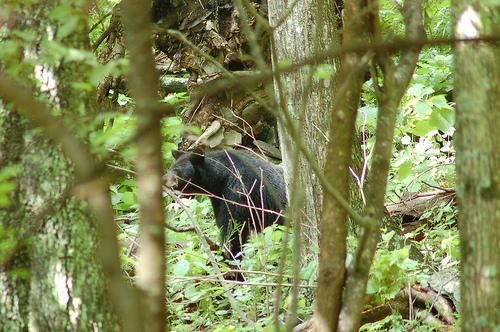Write a short overview of the main subject in the image and its setting. Black bear standing among trees, with a hole in dry log and bark of a tree visible. In a few words, describe the key object in the image and its immediate surroundings. Black bear in natural habitat among trunks of trees and dry twigs. Describe the image's central character and its backdrop in a single sentence. An omnivorous mammal is surrounded by green leaves and tree trunks in a wooded area. Provide a brief description of the primary subject and its surroundings in the image. A black bear is standing alert among trees in a forest, with a hillside above and dry log on the ground nearby. Share a concise description of the main subject in the image and its setting. Hungry bear on the prowl for food among the trees in a forest. Summarize the main subject and background details of the image. An ursine predator is standing among tree trunks and green leaves in the forest. Give a brief account of the central subject of the image and its environment. A focused bear stands in a forest among trunks of trees and green leaves. Give a simple overview of the central figure in the image and its environment. An alert bear is standing in a wooded area with trees surrounding it, and green leaves in the brushes. State the primary object in the image and its immediate context. Alert black bear among trees, with a hillside above and a dry log on the ground. Provide a succinct description of the image's main object and its surroundings. Bear with alert ears standing among trees, dry twigs, and a dry log nearby. 